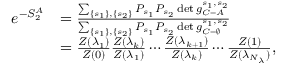<formula> <loc_0><loc_0><loc_500><loc_500>\begin{array} { r l } { e ^ { - S _ { 2 } ^ { A } } } & { = \frac { \sum _ { \left \{ s _ { 1 } \right \} , \left \{ s _ { 2 } \right \} } P _ { s _ { 1 } } P _ { s _ { 2 } } \det g _ { C = A } ^ { s _ { 1 } , s _ { 2 } } } { \sum _ { \left \{ s _ { 1 } \right \} , \left \{ s _ { 2 } \right \} } P _ { s _ { 1 } } P _ { s _ { 2 } } \det g _ { C = \varnothing } ^ { s _ { 1 } , s _ { 2 } } } } \\ & { = \frac { Z ( \lambda _ { 1 } ) } { Z ( 0 ) } \frac { Z ( \lambda _ { k } ) } { Z ( \lambda _ { 1 } ) } \cdots \frac { Z ( \lambda _ { k + 1 } ) } { Z ( \lambda _ { k } ) } \cdots \frac { Z ( 1 ) } { Z ( \lambda _ { N _ { \lambda } } ) } , } \end{array}</formula> 